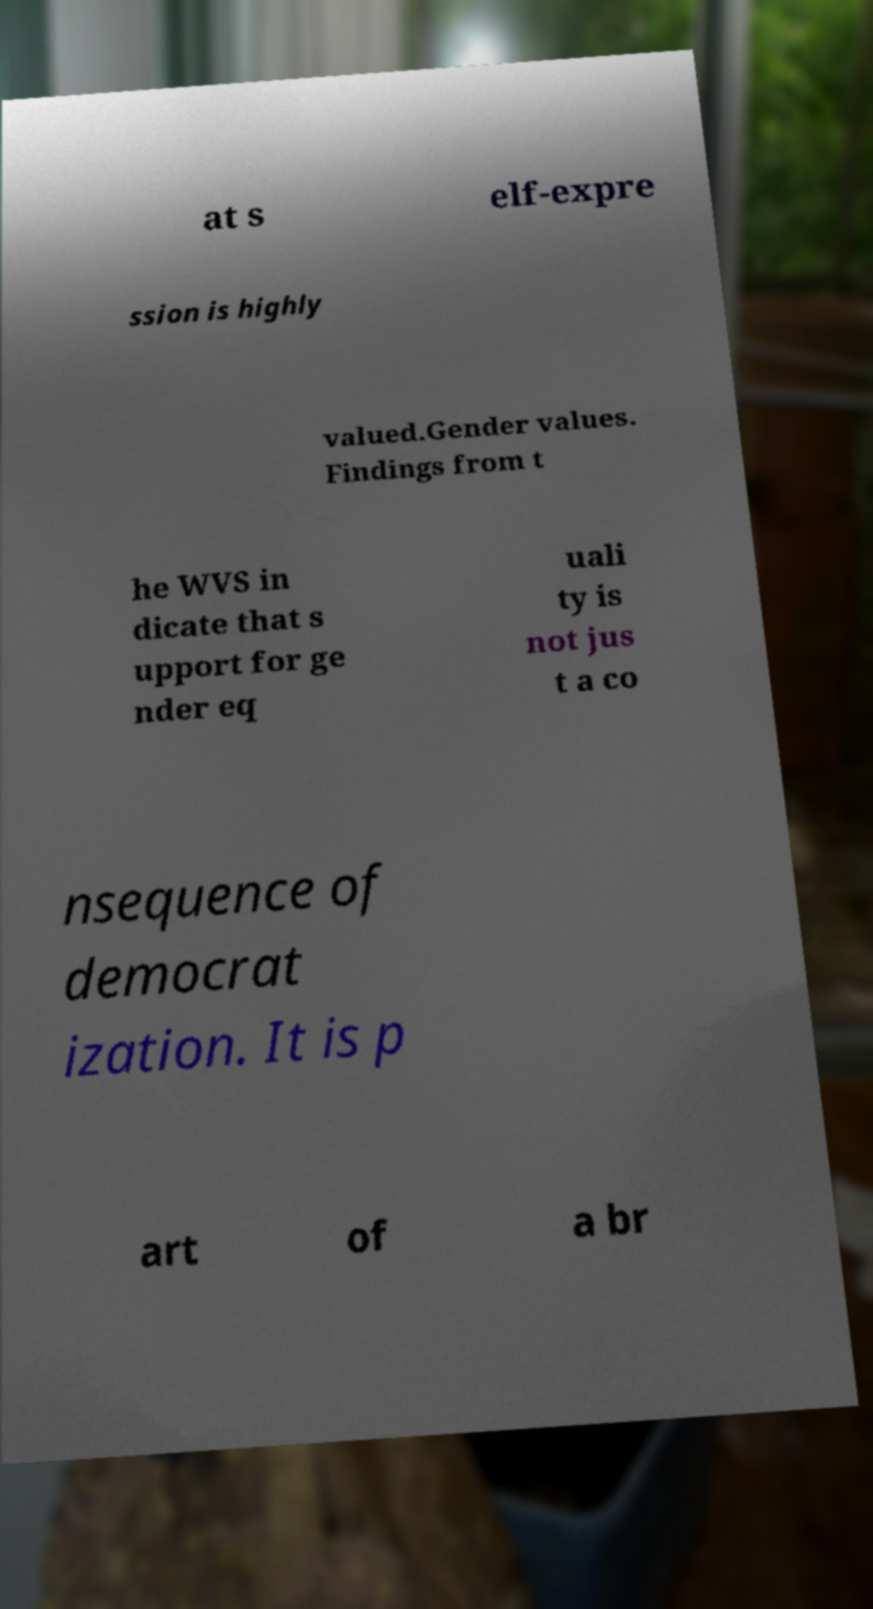For documentation purposes, I need the text within this image transcribed. Could you provide that? at s elf-expre ssion is highly valued.Gender values. Findings from t he WVS in dicate that s upport for ge nder eq uali ty is not jus t a co nsequence of democrat ization. It is p art of a br 